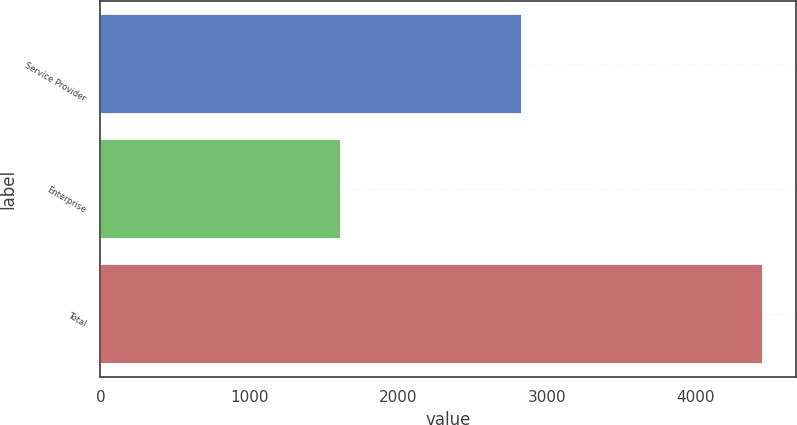Convert chart. <chart><loc_0><loc_0><loc_500><loc_500><bar_chart><fcel>Service Provider<fcel>Enterprise<fcel>Total<nl><fcel>2833<fcel>1615.7<fcel>4448.7<nl></chart> 